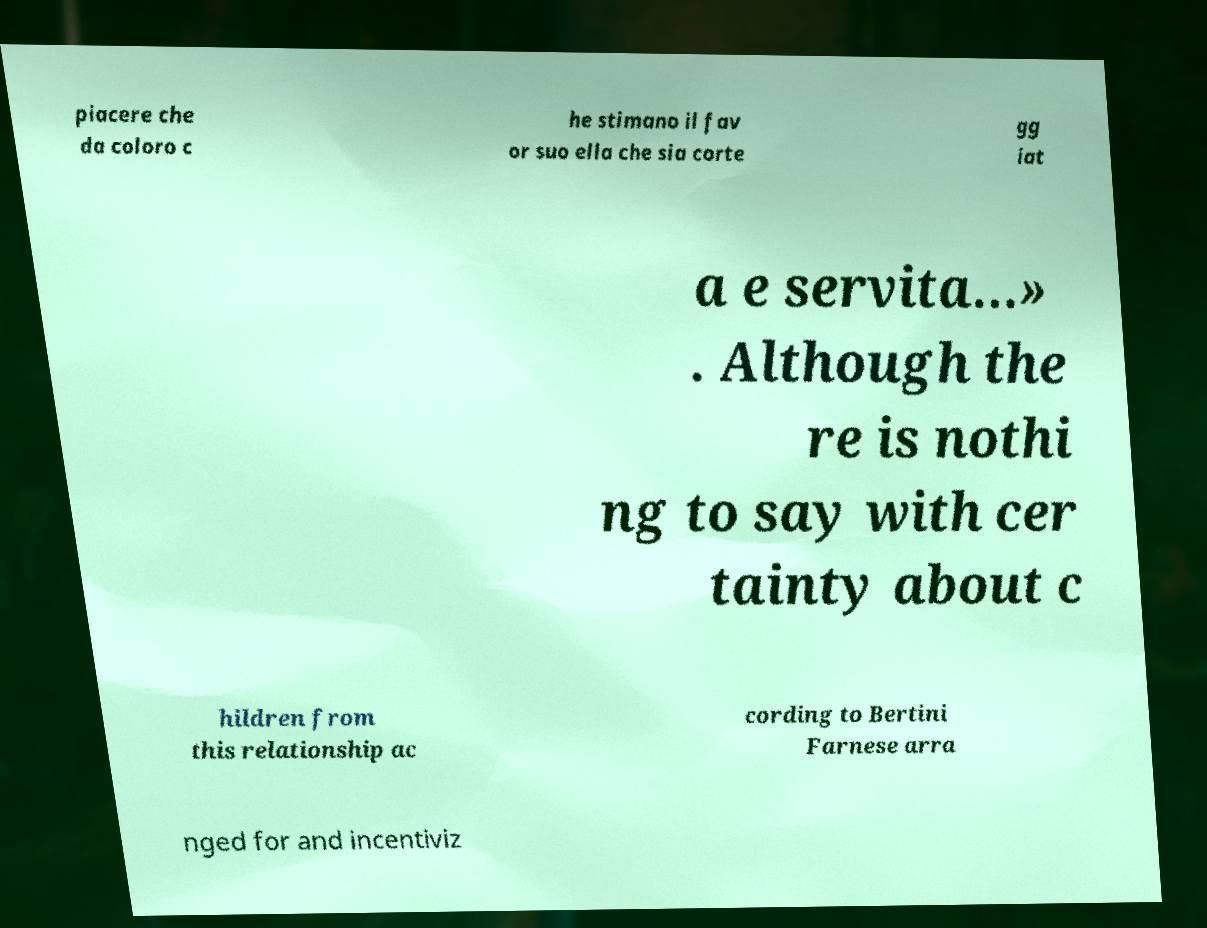Could you assist in decoding the text presented in this image and type it out clearly? piacere che da coloro c he stimano il fav or suo ella che sia corte gg iat a e servita…» . Although the re is nothi ng to say with cer tainty about c hildren from this relationship ac cording to Bertini Farnese arra nged for and incentiviz 